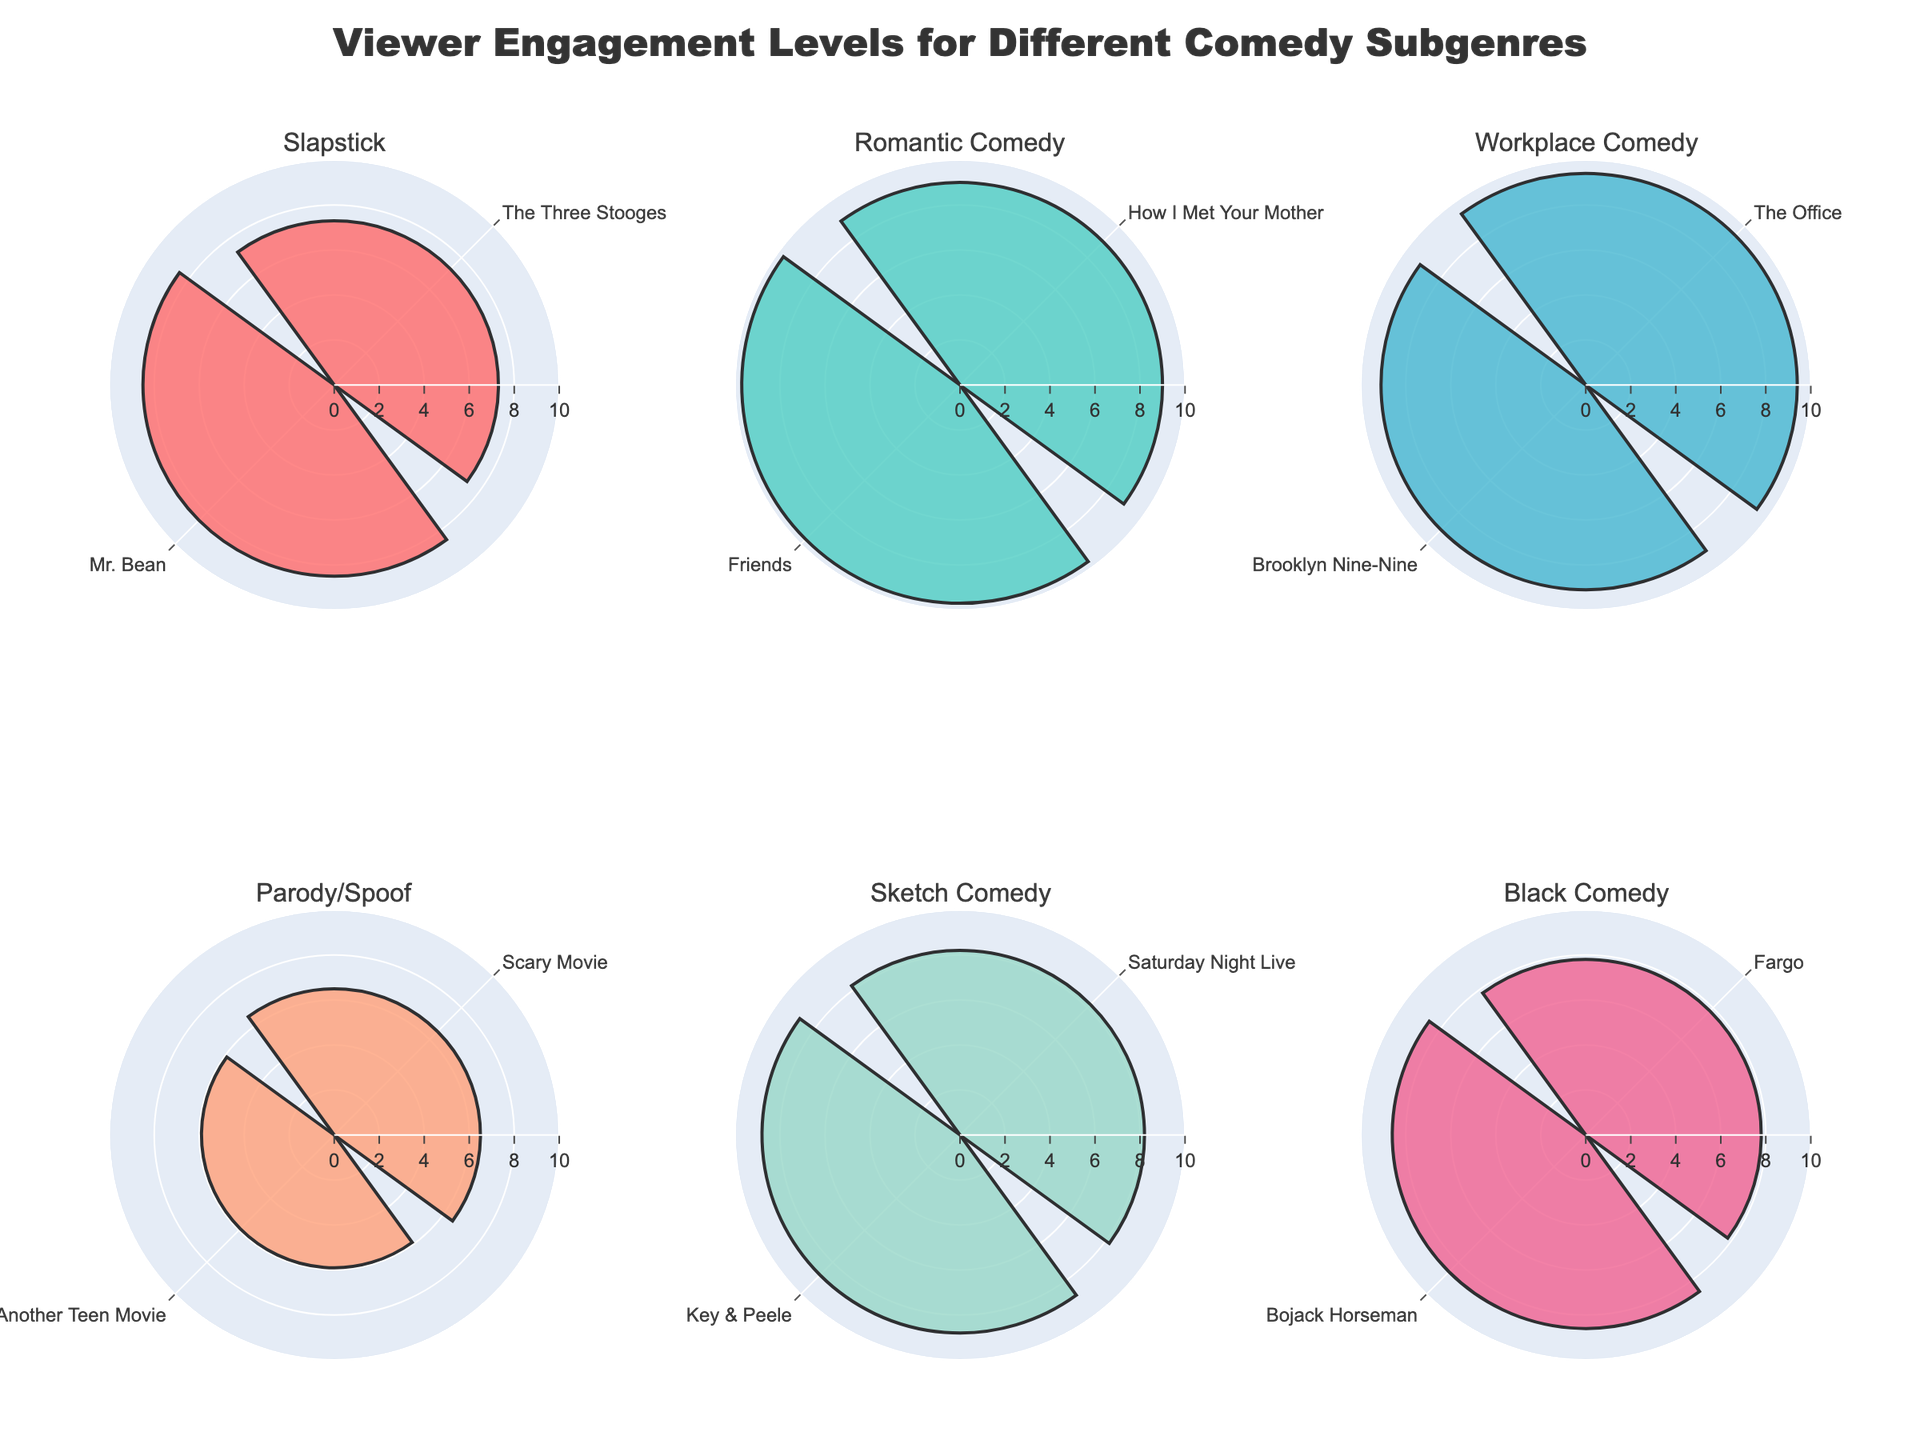Which comedy subgenre has the highest viewer engagement level? Look at the radial axis for each subplot and identify the bar that reaches the furthest out. The highest viewer engagement level is seen in the "Romantic Comedy" subplot, where "Friends" has a rating of 9.7, which is the highest in the chart.
Answer: Romantic Comedy What is the average viewer engagement level for the shows in the "Slapstick" subgenre? Identify the ratings for "The Three Stooges" (7.3) and "Mr. Bean" (8.5). Add these ratings together and divide by the number of shows in "Slapstick" (2). (7.3 + 8.5) / 2 = 7.9.
Answer: 7.9 How many shows are represented in the "Parody/Spoof" subplot? Count the number of bars within the "Parody/Spoof" subplot. There are two bars representing "Scary Movie" and "Not Another Teen Movie".
Answer: 2 Which age group is represented the most in the "Sketch Comedy" subgenre? Identify the age groups for the shows "Saturday Night Live" (18-49) and "Key & Peele" (18-34). Both age groups are represented, but only one show "Key & Peele" represents 18-34, so 18-49 is the most represented.
Answer: 18-49 How does the engagement duration compare between "Brooklyn Nine-Nine" and "The Office"? Check the length of the engagement duration in the "Workplace Comedy" subplot for both shows. "The Office" has a duration of 55 minutes while "Brooklyn Nine-Nine" is at 50 minutes. The engagement duration is longer for "The Office".
Answer: The Office has longer duration Which subgenre has the lowest viewer engagement level overall? Look at the bar that reaches the shortest radial distance out of all the subplots. The lowest viewer engagement level is in the "Parody/Spoof" subplot for "Not Another Teen Movie" with a rating of 5.9.
Answer: Parody/Spoof What is the difference in viewer engagement levels between "Friends" and "How I Met Your Mother"? Identify the viewer engagement level for "Friends" (9.7) and "How I Met Your Mother" (9.0). Subtract the smaller rating from the larger one. 9.7 - 9.0 = 0.7.
Answer: 0.7 Which show within the "Black Comedy" subgenre has the higher viewer engagement level? Compare the heights of the bars in the "Black Comedy" subplot for "Fargo" (7.8) and "Bojack Horseman" (8.6). "Bojack Horseman" has the higher engagement level.
Answer: Bojack Horseman What is the combined viewer engagement level for all shows in the "Workplace Comedy" subgenre? Sum the engagement levels of "The Office" (9.4) and "Brooklyn Nine-Nine" (9.1). 9.4 + 9.1 = 18.5.
Answer: 18.5 Which comedy subgenre has the most consistently high viewer engagement levels? Identify the subgenres where the differences between the smallest and largest bars are minimal and relatively high. "Romantic Comedy" has both shows, "Friends" (9.7) and "How I Met Your Mother" (9.0), with high and consistent ratings.
Answer: Romantic Comedy 